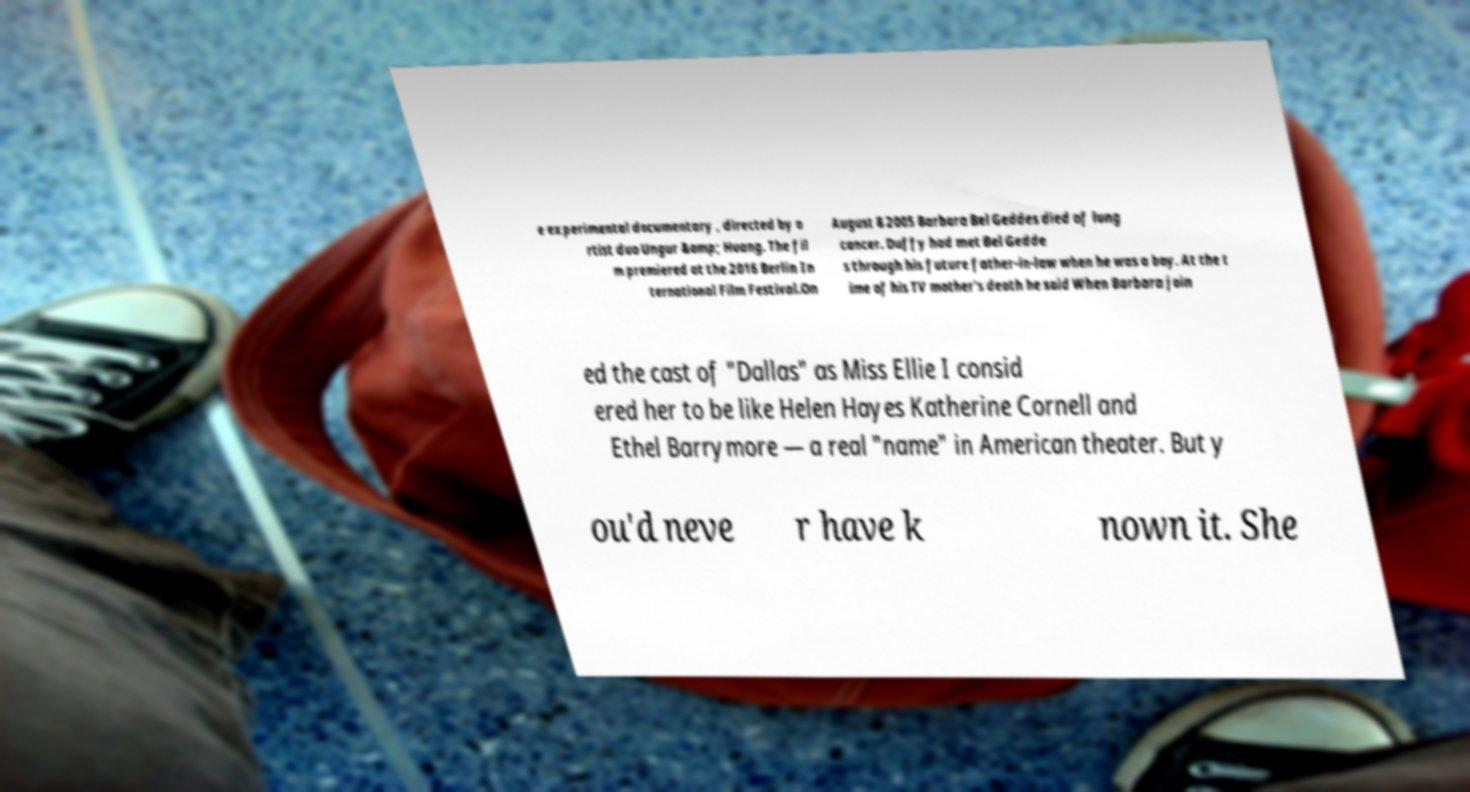Could you extract and type out the text from this image? e experimental documentary , directed by a rtist duo Ungur &amp; Huang. The fil m premiered at the 2016 Berlin In ternational Film Festival.On August 8 2005 Barbara Bel Geddes died of lung cancer. Duffy had met Bel Gedde s through his future father-in-law when he was a boy. At the t ime of his TV mother's death he said When Barbara join ed the cast of "Dallas" as Miss Ellie I consid ered her to be like Helen Hayes Katherine Cornell and Ethel Barrymore — a real "name" in American theater. But y ou'd neve r have k nown it. She 